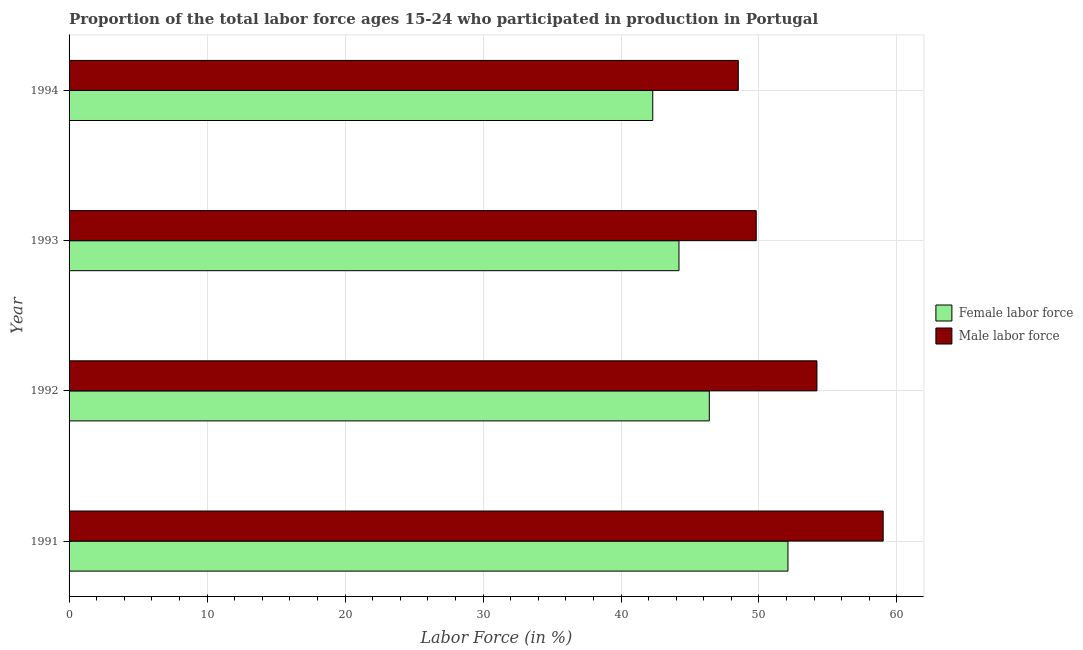How many different coloured bars are there?
Offer a terse response. 2. Are the number of bars per tick equal to the number of legend labels?
Provide a short and direct response. Yes. Are the number of bars on each tick of the Y-axis equal?
Keep it short and to the point. Yes. How many bars are there on the 4th tick from the top?
Give a very brief answer. 2. How many bars are there on the 1st tick from the bottom?
Keep it short and to the point. 2. What is the percentage of male labour force in 1992?
Provide a succinct answer. 54.2. Across all years, what is the maximum percentage of female labor force?
Ensure brevity in your answer.  52.1. Across all years, what is the minimum percentage of male labour force?
Your response must be concise. 48.5. In which year was the percentage of male labour force maximum?
Provide a succinct answer. 1991. What is the total percentage of male labour force in the graph?
Offer a terse response. 211.5. What is the difference between the percentage of male labour force in 1992 and the percentage of female labor force in 1993?
Provide a short and direct response. 10. What is the average percentage of male labour force per year?
Offer a very short reply. 52.88. What is the ratio of the percentage of male labour force in 1991 to that in 1993?
Keep it short and to the point. 1.19. Is the percentage of female labor force in 1991 less than that in 1992?
Keep it short and to the point. No. Is the difference between the percentage of female labor force in 1992 and 1994 greater than the difference between the percentage of male labour force in 1992 and 1994?
Keep it short and to the point. No. Is the sum of the percentage of male labour force in 1991 and 1993 greater than the maximum percentage of female labor force across all years?
Your response must be concise. Yes. What does the 1st bar from the top in 1991 represents?
Provide a succinct answer. Male labor force. What does the 2nd bar from the bottom in 1994 represents?
Give a very brief answer. Male labor force. How many years are there in the graph?
Keep it short and to the point. 4. Are the values on the major ticks of X-axis written in scientific E-notation?
Provide a succinct answer. No. Does the graph contain any zero values?
Your answer should be very brief. No. Does the graph contain grids?
Offer a very short reply. Yes. Where does the legend appear in the graph?
Offer a very short reply. Center right. How many legend labels are there?
Ensure brevity in your answer.  2. What is the title of the graph?
Provide a short and direct response. Proportion of the total labor force ages 15-24 who participated in production in Portugal. What is the label or title of the Y-axis?
Offer a terse response. Year. What is the Labor Force (in %) of Female labor force in 1991?
Make the answer very short. 52.1. What is the Labor Force (in %) in Female labor force in 1992?
Provide a succinct answer. 46.4. What is the Labor Force (in %) in Male labor force in 1992?
Give a very brief answer. 54.2. What is the Labor Force (in %) of Female labor force in 1993?
Offer a very short reply. 44.2. What is the Labor Force (in %) of Male labor force in 1993?
Keep it short and to the point. 49.8. What is the Labor Force (in %) of Female labor force in 1994?
Provide a short and direct response. 42.3. What is the Labor Force (in %) in Male labor force in 1994?
Your answer should be very brief. 48.5. Across all years, what is the maximum Labor Force (in %) of Female labor force?
Your answer should be compact. 52.1. Across all years, what is the minimum Labor Force (in %) of Female labor force?
Offer a very short reply. 42.3. Across all years, what is the minimum Labor Force (in %) of Male labor force?
Offer a terse response. 48.5. What is the total Labor Force (in %) in Female labor force in the graph?
Your answer should be compact. 185. What is the total Labor Force (in %) in Male labor force in the graph?
Provide a succinct answer. 211.5. What is the difference between the Labor Force (in %) in Male labor force in 1991 and that in 1992?
Your answer should be compact. 4.8. What is the difference between the Labor Force (in %) in Male labor force in 1991 and that in 1993?
Offer a very short reply. 9.2. What is the difference between the Labor Force (in %) of Male labor force in 1991 and that in 1994?
Ensure brevity in your answer.  10.5. What is the difference between the Labor Force (in %) of Female labor force in 1992 and that in 1993?
Provide a succinct answer. 2.2. What is the difference between the Labor Force (in %) of Female labor force in 1992 and that in 1994?
Keep it short and to the point. 4.1. What is the difference between the Labor Force (in %) in Male labor force in 1992 and that in 1994?
Ensure brevity in your answer.  5.7. What is the difference between the Labor Force (in %) in Female labor force in 1993 and that in 1994?
Provide a succinct answer. 1.9. What is the difference between the Labor Force (in %) in Female labor force in 1991 and the Labor Force (in %) in Male labor force in 1992?
Provide a short and direct response. -2.1. What is the difference between the Labor Force (in %) in Female labor force in 1991 and the Labor Force (in %) in Male labor force in 1994?
Keep it short and to the point. 3.6. What is the difference between the Labor Force (in %) in Female labor force in 1992 and the Labor Force (in %) in Male labor force in 1993?
Ensure brevity in your answer.  -3.4. What is the difference between the Labor Force (in %) in Female labor force in 1992 and the Labor Force (in %) in Male labor force in 1994?
Offer a very short reply. -2.1. What is the difference between the Labor Force (in %) of Female labor force in 1993 and the Labor Force (in %) of Male labor force in 1994?
Provide a succinct answer. -4.3. What is the average Labor Force (in %) of Female labor force per year?
Provide a succinct answer. 46.25. What is the average Labor Force (in %) of Male labor force per year?
Provide a succinct answer. 52.88. In the year 1993, what is the difference between the Labor Force (in %) in Female labor force and Labor Force (in %) in Male labor force?
Offer a very short reply. -5.6. In the year 1994, what is the difference between the Labor Force (in %) of Female labor force and Labor Force (in %) of Male labor force?
Ensure brevity in your answer.  -6.2. What is the ratio of the Labor Force (in %) in Female labor force in 1991 to that in 1992?
Provide a succinct answer. 1.12. What is the ratio of the Labor Force (in %) of Male labor force in 1991 to that in 1992?
Your answer should be compact. 1.09. What is the ratio of the Labor Force (in %) of Female labor force in 1991 to that in 1993?
Give a very brief answer. 1.18. What is the ratio of the Labor Force (in %) of Male labor force in 1991 to that in 1993?
Offer a very short reply. 1.18. What is the ratio of the Labor Force (in %) in Female labor force in 1991 to that in 1994?
Offer a very short reply. 1.23. What is the ratio of the Labor Force (in %) of Male labor force in 1991 to that in 1994?
Offer a very short reply. 1.22. What is the ratio of the Labor Force (in %) of Female labor force in 1992 to that in 1993?
Offer a very short reply. 1.05. What is the ratio of the Labor Force (in %) of Male labor force in 1992 to that in 1993?
Ensure brevity in your answer.  1.09. What is the ratio of the Labor Force (in %) in Female labor force in 1992 to that in 1994?
Provide a succinct answer. 1.1. What is the ratio of the Labor Force (in %) of Male labor force in 1992 to that in 1994?
Your response must be concise. 1.12. What is the ratio of the Labor Force (in %) in Female labor force in 1993 to that in 1994?
Give a very brief answer. 1.04. What is the ratio of the Labor Force (in %) of Male labor force in 1993 to that in 1994?
Offer a terse response. 1.03. What is the difference between the highest and the lowest Labor Force (in %) of Male labor force?
Make the answer very short. 10.5. 